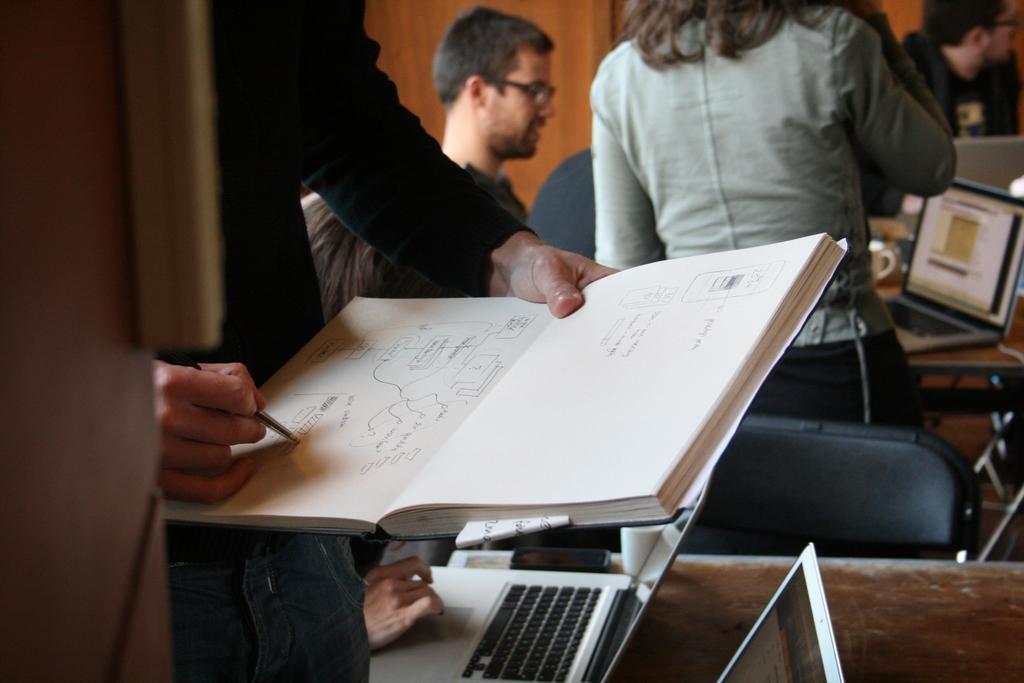How would you summarize this image in a sentence or two? In this picture we can see one woman standing here and one person is sitting here and one person standing here and holding a book and writing something on the book and another person is is operating a laptop and the woman is looking into the laptop. 